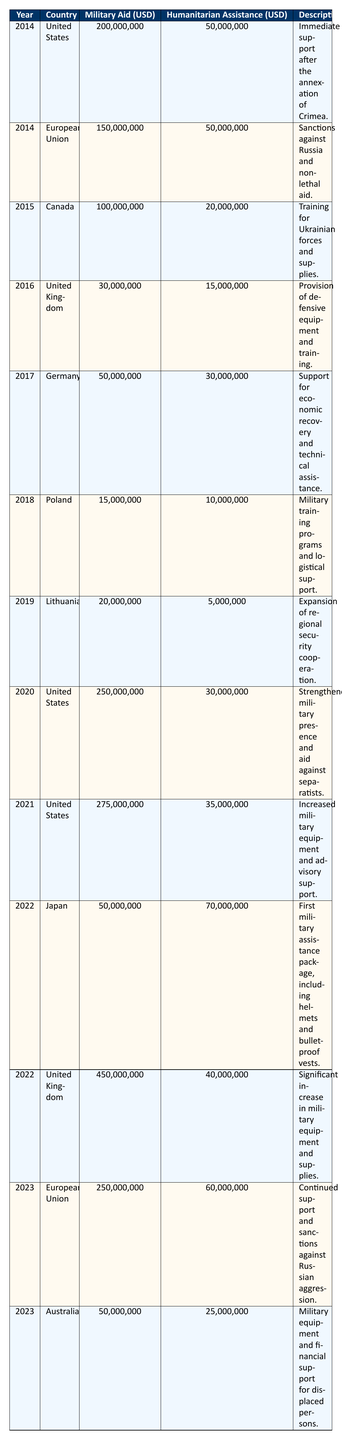What was the total military aid provided by the United States to Ukraine from 2014 to 2021? The military aid from the United States over the years is: 200,000,000 (2014) + 250,000,000 (2020) + 275,000,000 (2021) = 725,000,000. Thus, the total military aid from 2014 to 2021 is 200,000,000 + 250,000,000 + 275,000,000 = 725,000,000.
Answer: 725,000,000 Which country provided the highest military aid in 2022? Looking at the 2022 entries, the United Kingdom provided 450,000,000, which is higher than Japan's 50,000,000. Therefore, the highest military aid in 2022 was from the United Kingdom.
Answer: United Kingdom Did Germany provide more humanitarian assistance than military aid in 2017? Checking the values for Germany in 2017, they provided 30,000,000 in humanitarian assistance and 50,000,000 in military aid. Since 30,000,000 is less than 50,000,000, the statement is false.
Answer: No What is the average military aid provided by the European Union from 2014 to 2023? The military aid from the European Union is 150,000,000 (2014) + 250,000,000 (2023) = 400,000,000 over 2 years. The average is calculated by dividing the total by the number of years: 400,000,000 / 2 = 200,000,000.
Answer: 200,000,000 In which year did Ukraine receive the most overall assistance (military aid + humanitarian assistance) from the United States? The total assistance from the United States over the years is: 200,000,000 + 50,000,000 (2014), 250,000,000 + 30,000,000 (2020), and 275,000,000 + 35,000,000 (2021). Calculating these: 250,000,000 + 30,000,000 = 280,000,000 (2020) and 275,000,000 + 35,000,000 = 310,000,000 (2021). The highest overall assistance is in 2021 at 310,000,000.
Answer: 2021 